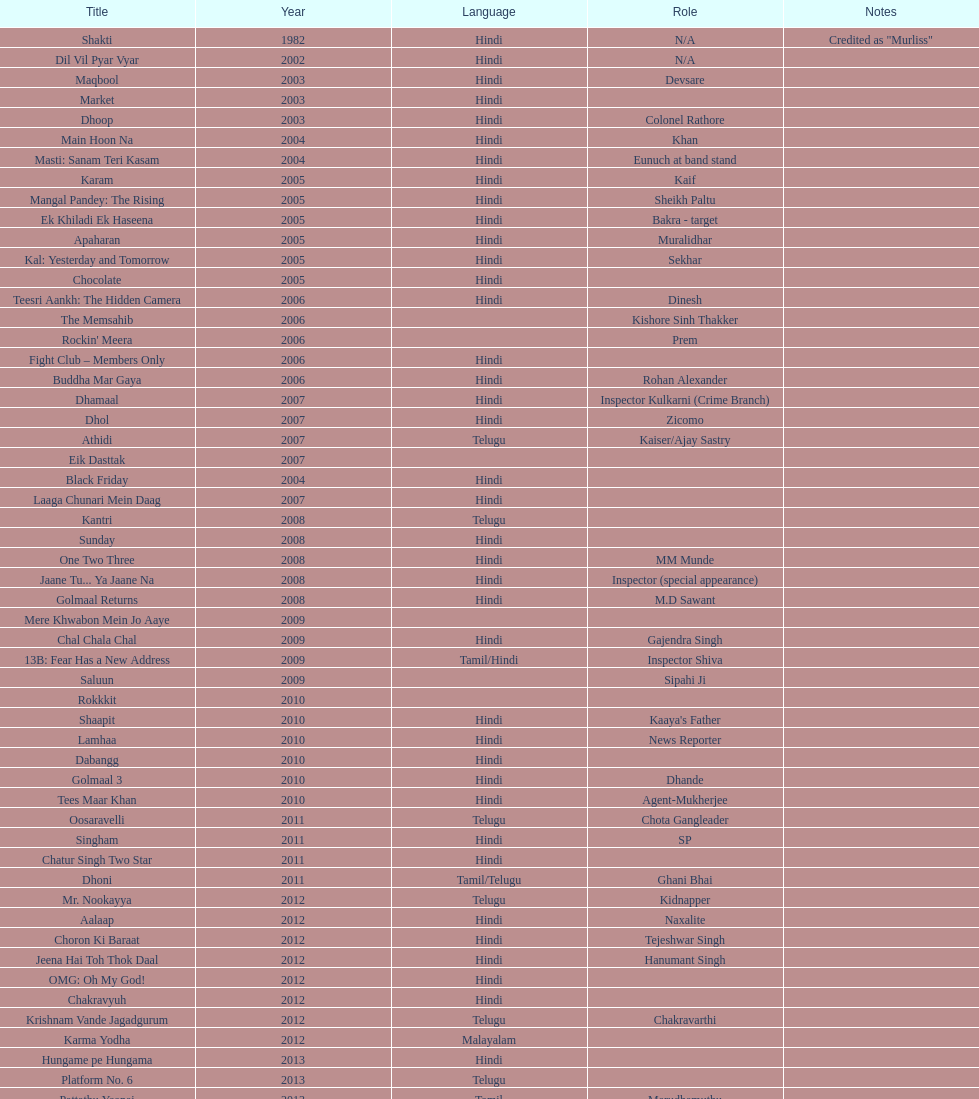Which motion picture featured this actor subsequent to starring in dil vil pyar vyar in 2002? Maqbool. 